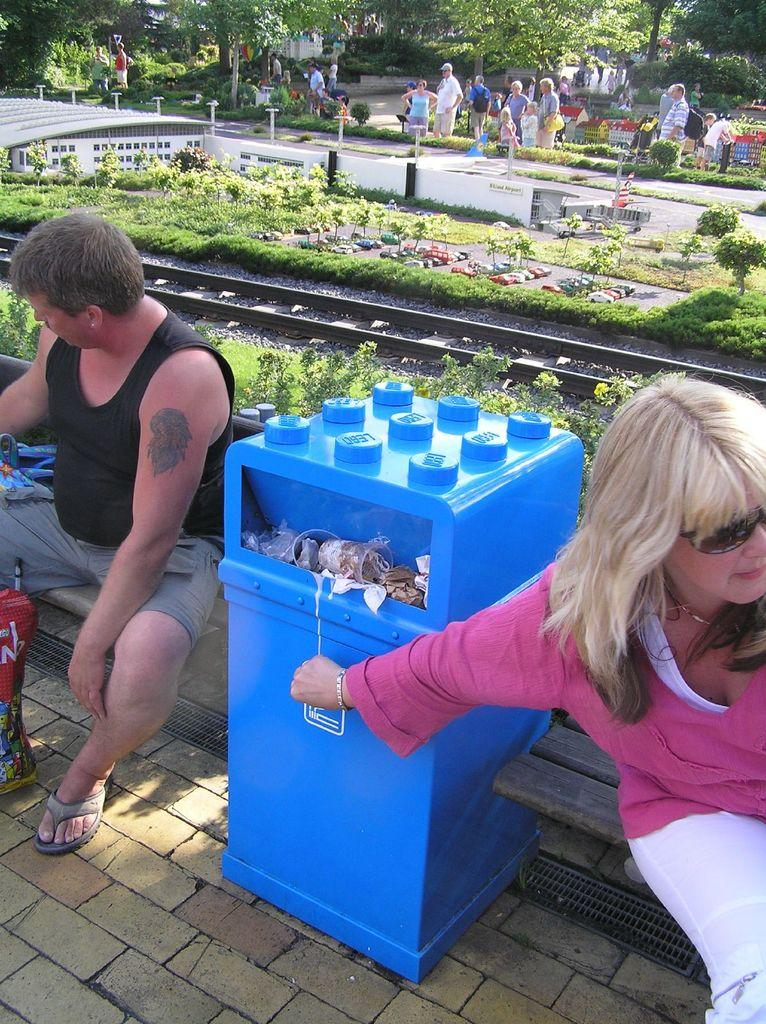How many people are sitting in the image? There are two people sitting in the image. What is located between the two people? There is a trash bin between the two people. What can be seen in the background of the image? There is grass, plants, people, and trees in the background of the image. What is the title of the ship that is visible in the image? There is no ship present in the image, so there is no title to be determined. 